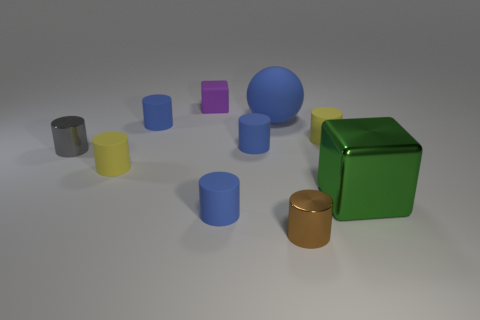There is a small matte object behind the large ball on the left side of the big green metallic thing; what color is it?
Your response must be concise. Purple. Is there a cylinder of the same color as the large rubber ball?
Provide a short and direct response. Yes. There is a matte block that is the same size as the brown cylinder; what is its color?
Offer a terse response. Purple. Do the small yellow object to the right of the tiny brown cylinder and the green cube have the same material?
Make the answer very short. No. There is a big object in front of the tiny yellow matte object that is to the right of the small matte block; are there any purple matte cubes that are to the right of it?
Offer a very short reply. No. Is the shape of the large object in front of the tiny gray cylinder the same as  the large matte object?
Offer a terse response. No. What is the shape of the small yellow matte thing in front of the tiny yellow matte cylinder that is behind the tiny gray metallic cylinder?
Make the answer very short. Cylinder. How big is the cylinder on the right side of the tiny metallic thing that is in front of the small metallic cylinder behind the large green cube?
Give a very brief answer. Small. What is the color of the shiny object that is the same shape as the tiny purple rubber object?
Your answer should be very brief. Green. Does the purple rubber block have the same size as the blue rubber ball?
Your answer should be compact. No. 